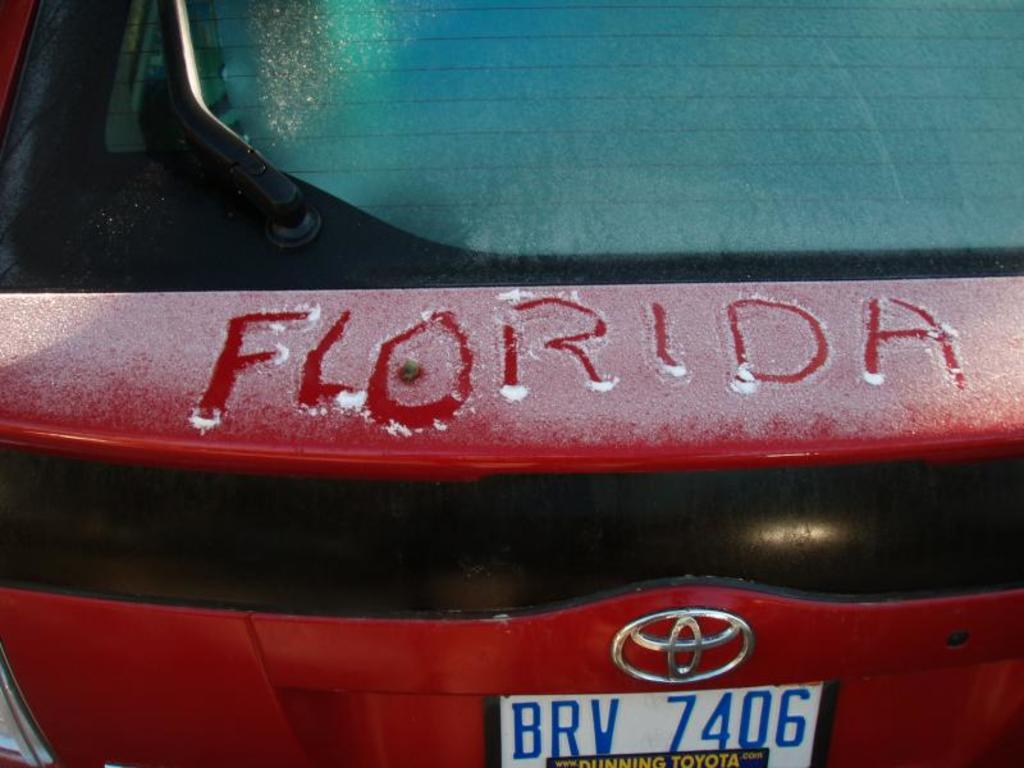<image>
Offer a succinct explanation of the picture presented. The state name Florida is drawn into a thin layer of snow, on the back of a red car. 